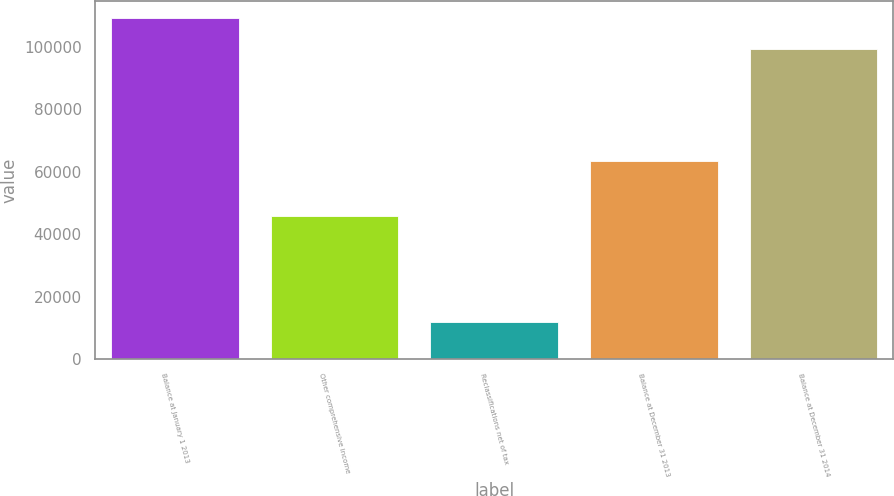Convert chart to OTSL. <chart><loc_0><loc_0><loc_500><loc_500><bar_chart><fcel>Balance at January 1 2013<fcel>Other comprehensive income<fcel>Reclassifications net of tax<fcel>Balance at December 31 2013<fcel>Balance at December 31 2014<nl><fcel>109283<fcel>45930<fcel>11938<fcel>63353<fcel>99449<nl></chart> 